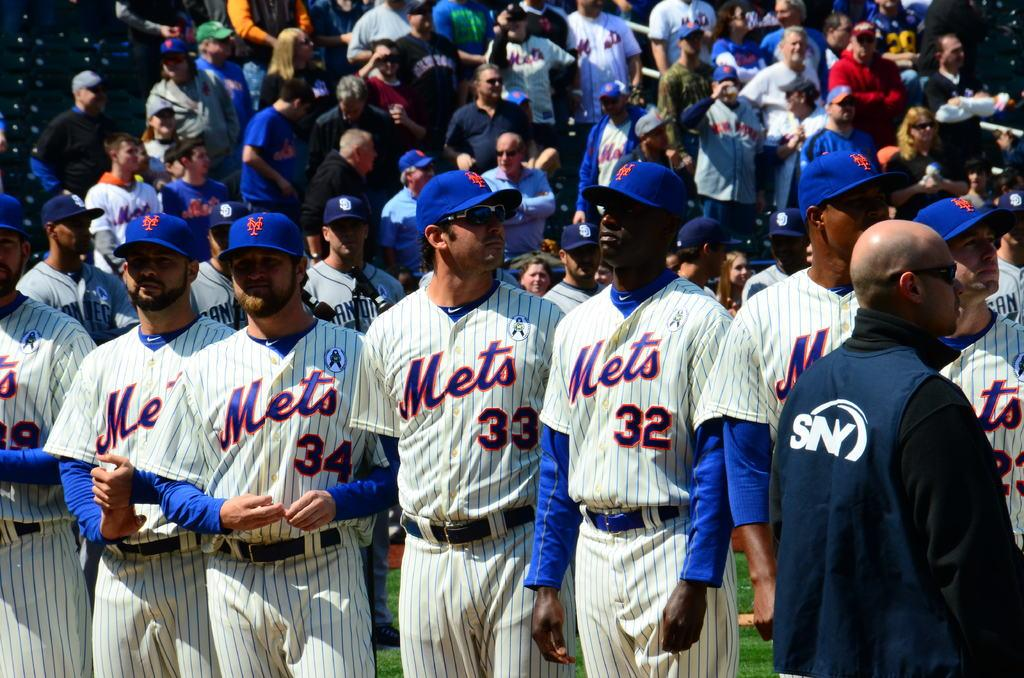<image>
Create a compact narrative representing the image presented. Six New York Mets in uniform in a row, including number's 32, 33, and 34. 